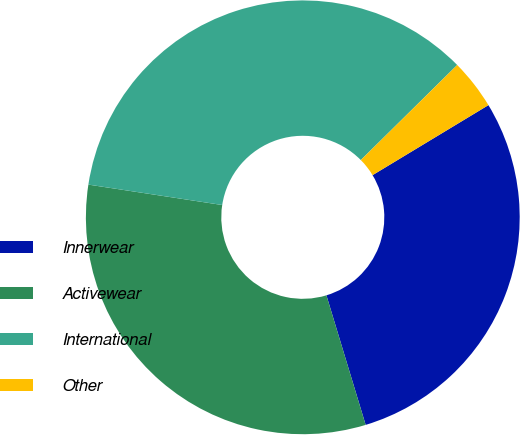Convert chart. <chart><loc_0><loc_0><loc_500><loc_500><pie_chart><fcel>Innerwear<fcel>Activewear<fcel>International<fcel>Other<nl><fcel>28.97%<fcel>32.09%<fcel>35.2%<fcel>3.74%<nl></chart> 